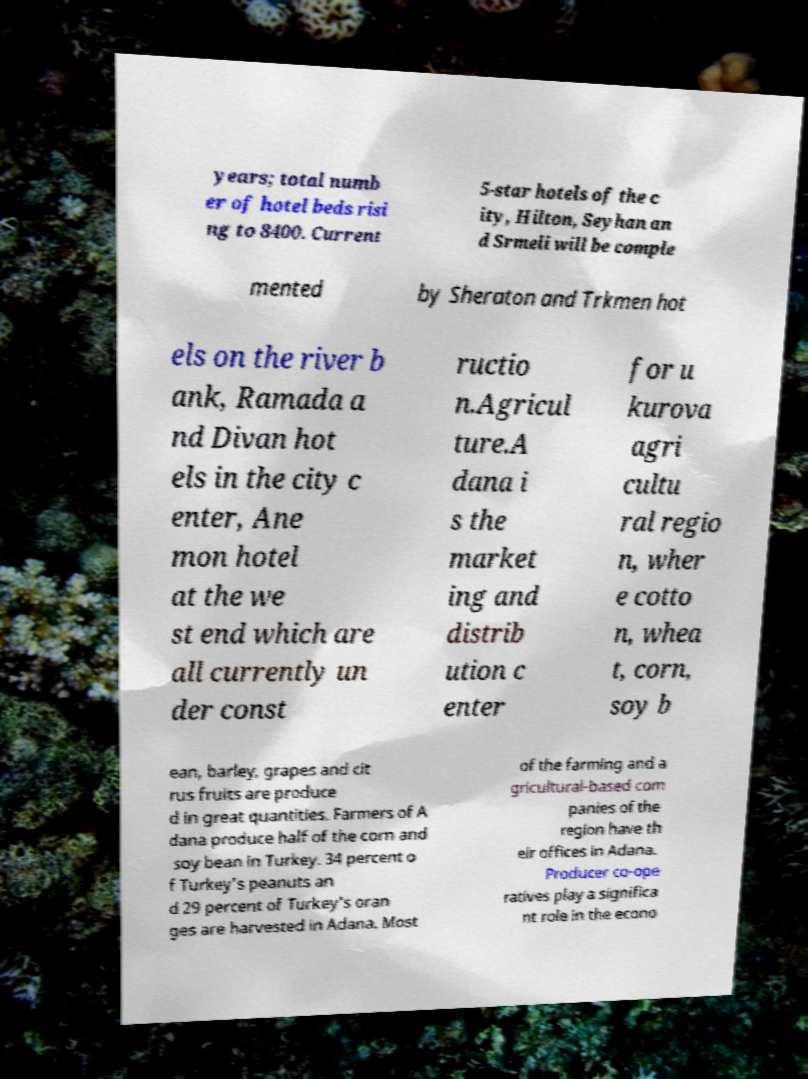There's text embedded in this image that I need extracted. Can you transcribe it verbatim? years; total numb er of hotel beds risi ng to 8400. Current 5-star hotels of the c ity, Hilton, Seyhan an d Srmeli will be comple mented by Sheraton and Trkmen hot els on the river b ank, Ramada a nd Divan hot els in the city c enter, Ane mon hotel at the we st end which are all currently un der const ructio n.Agricul ture.A dana i s the market ing and distrib ution c enter for u kurova agri cultu ral regio n, wher e cotto n, whea t, corn, soy b ean, barley, grapes and cit rus fruits are produce d in great quantities. Farmers of A dana produce half of the corn and soy bean in Turkey. 34 percent o f Turkey's peanuts an d 29 percent of Turkey's oran ges are harvested in Adana. Most of the farming and a gricultural-based com panies of the region have th eir offices in Adana. Producer co-ope ratives play a significa nt role in the econo 